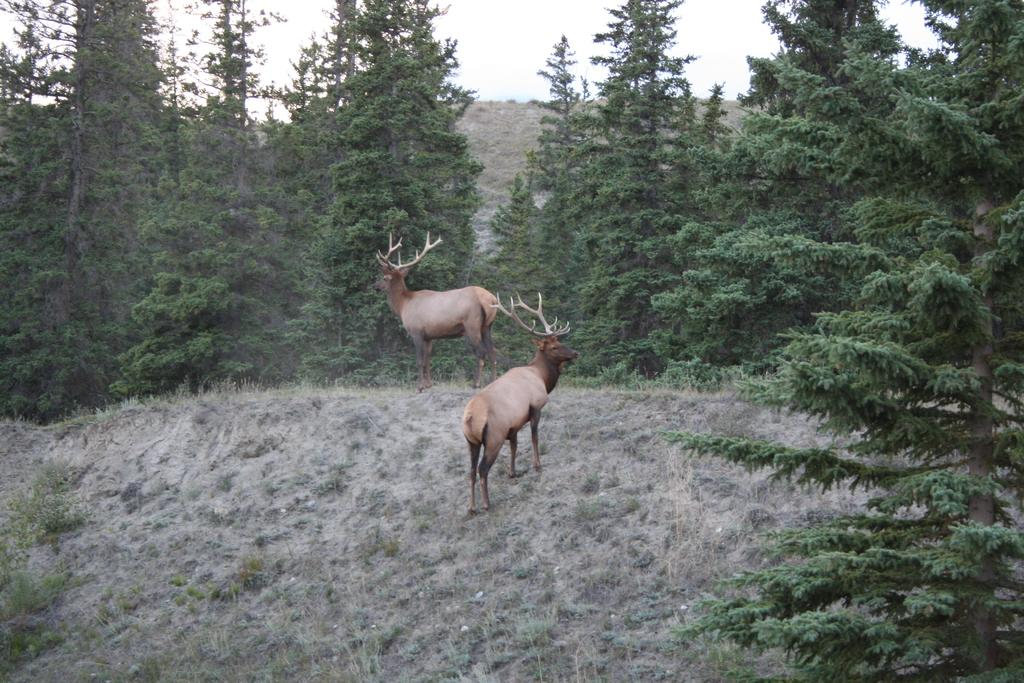What type of animals can be seen in the image? There are animals on the ground in the image. What can be seen in the background of the image? There are trees and a hill in the background of the image. What type of class is being taught in the image? There is no class or teaching activity present in the image. 